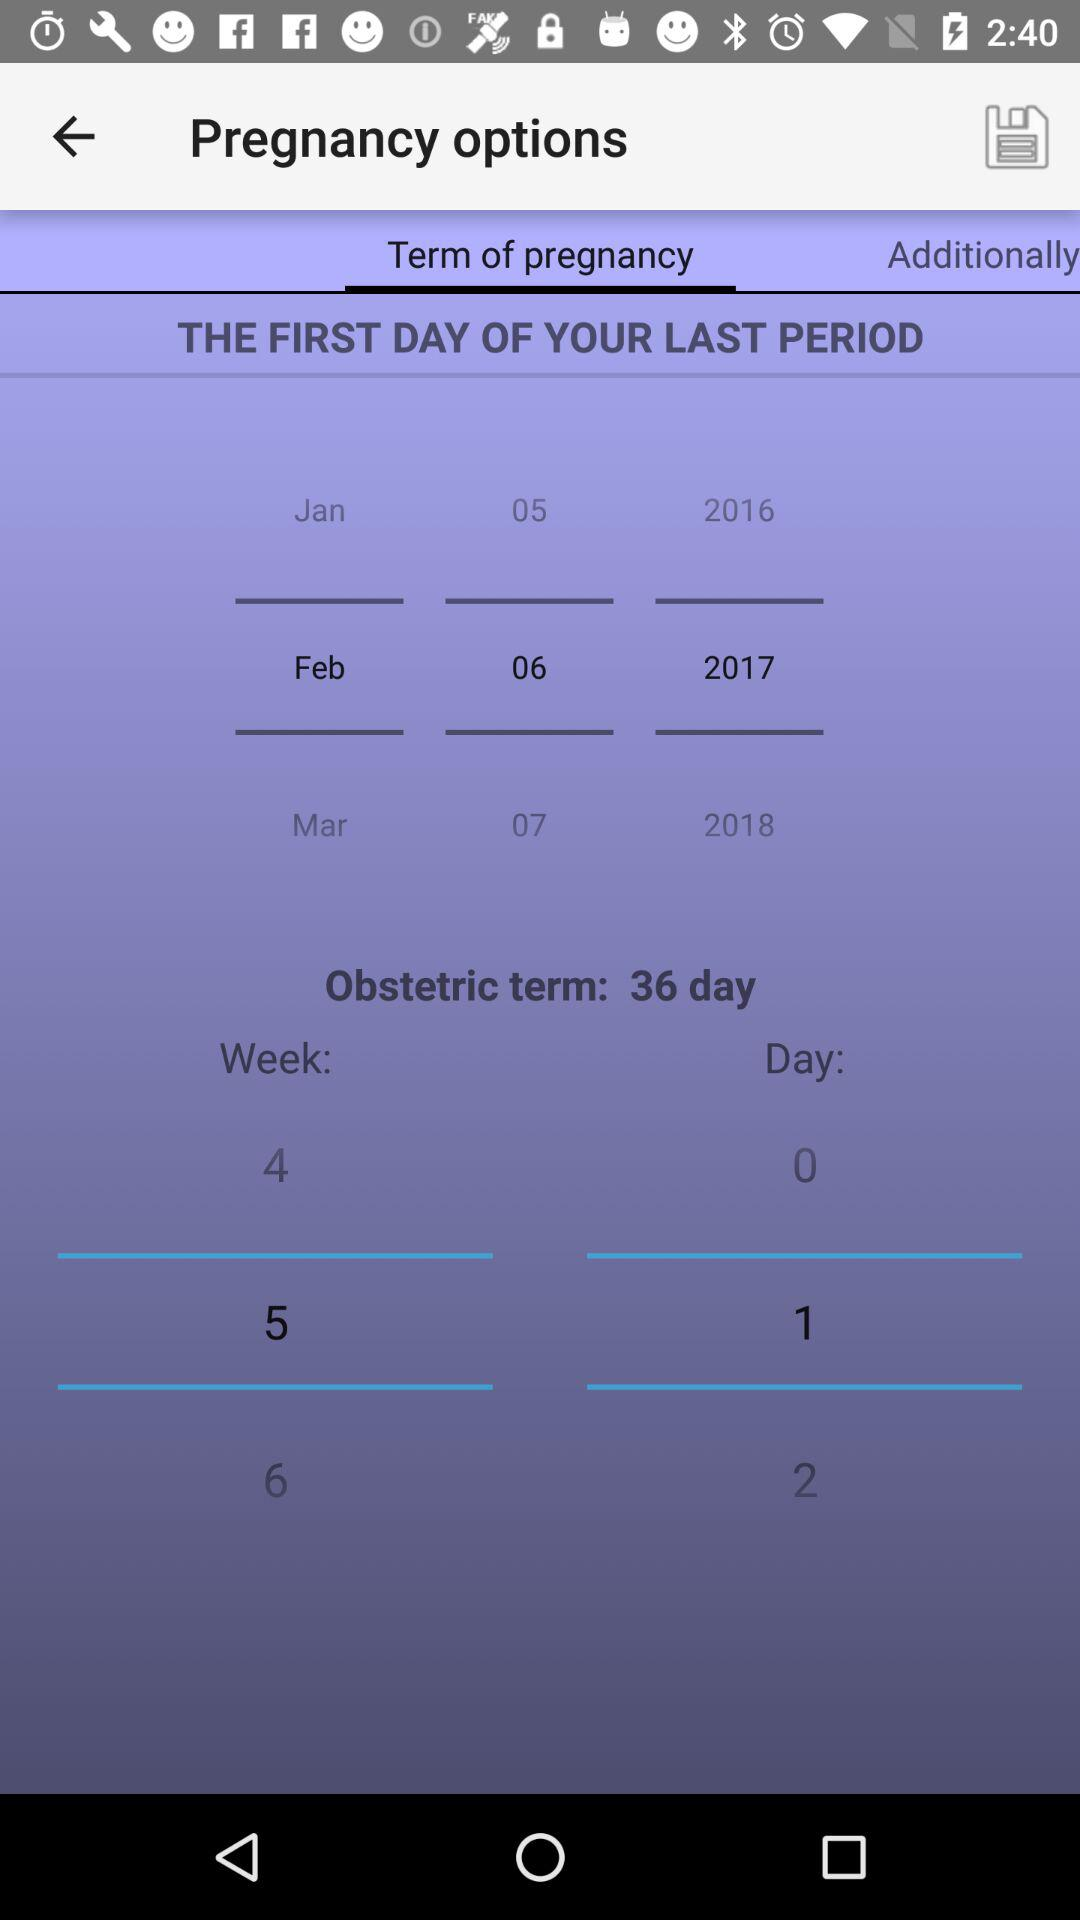How many days is the "Obstetric term"? The "Obstetric term" is for 36 days. 